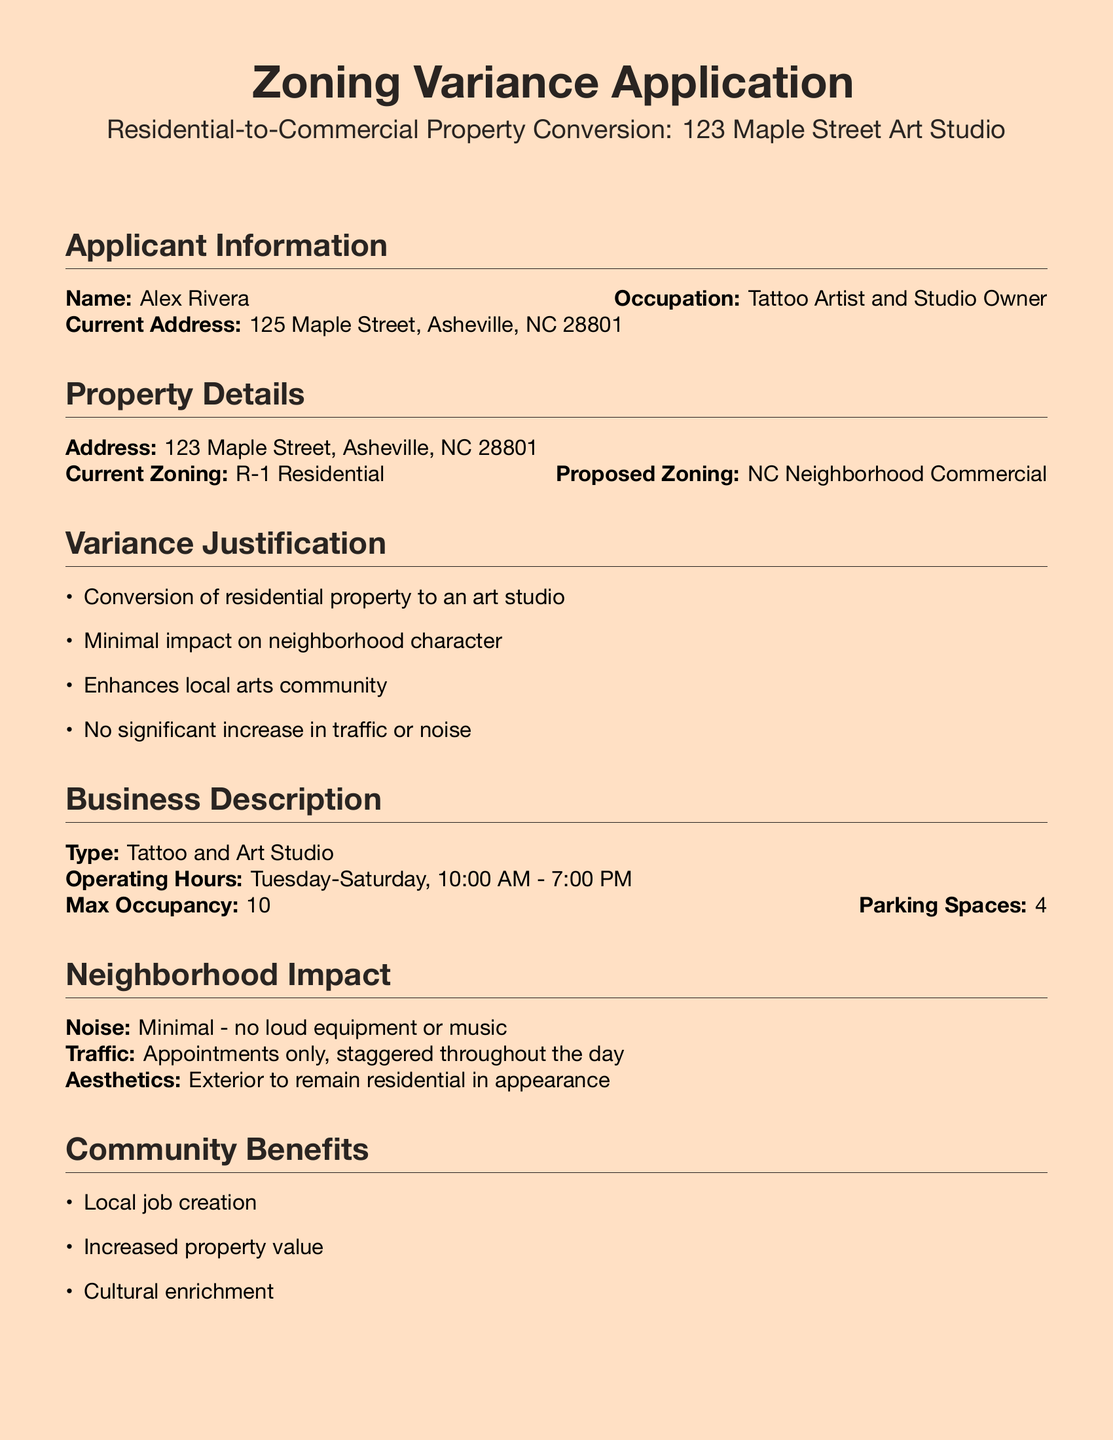What is the name of the applicant? The name of the applicant is explicitly mentioned in the document under "Applicant Information."
Answer: Alex Rivera What is the proposed zoning classification? The proposed zoning classification is stated in the "Property Details" section of the document.
Answer: NC Neighborhood Commercial What is the maximum occupancy of the studio? The maximum occupancy is provided in the "Business Description" section of the document.
Answer: 10 What are the operating hours of the studio? The operating hours can be found in the "Business Description" and are specifically listed there.
Answer: Tuesday-Saturday, 10:00 AM - 7:00 PM What type of business is being proposed? The type of business is detailed in the "Business Description" section.
Answer: Tattoo and Art Studio How many parking spaces are indicated for the studio? The number of parking spaces is mentioned in the "Business Description" section.
Answer: 4 What is the current zoning classification of the property? The current zoning classification is specified in the "Property Details" section of the document.
Answer: R-1 Residential What are two community benefits mentioned in the document? Community benefits are listed in the "Community Benefits" section, which outlines multiple advantages.
Answer: Local job creation, Increased property value What document is required for the variance application? The documents required can be found in the "Required Documents" section.
Answer: Site plan (any one is sufficient) 